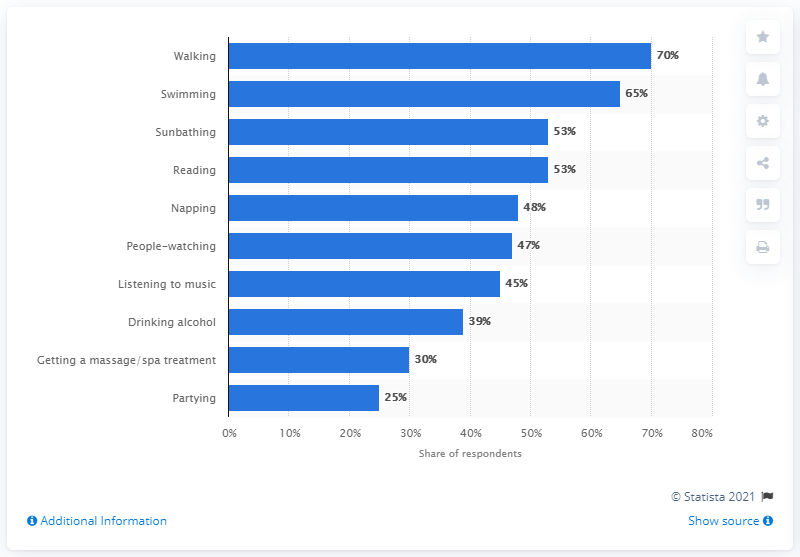Indicate a few pertinent items in this graphic. According to a survey, walking is the most popular beach vacation activity, with a majority of respondents reporting a preference for walking at 70%. There are six activities that are below 50%. 